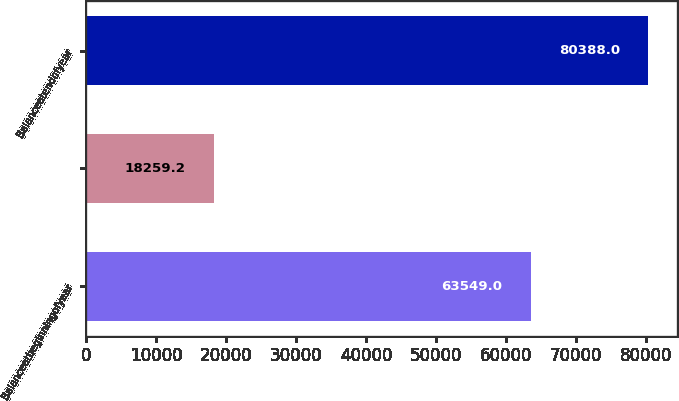Convert chart. <chart><loc_0><loc_0><loc_500><loc_500><bar_chart><fcel>Balanceatbeginningofyear<fcel>Unnamed: 1<fcel>Balanceatendofyear<nl><fcel>63549<fcel>18259.2<fcel>80388<nl></chart> 